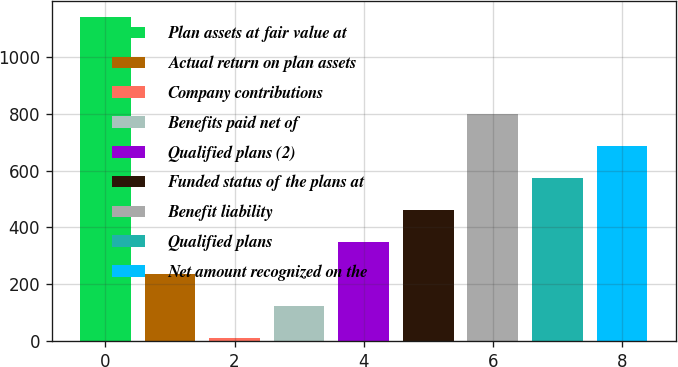Convert chart to OTSL. <chart><loc_0><loc_0><loc_500><loc_500><bar_chart><fcel>Plan assets at fair value at<fcel>Actual return on plan assets<fcel>Company contributions<fcel>Benefits paid net of<fcel>Qualified plans (2)<fcel>Funded status of the plans at<fcel>Benefit liability<fcel>Qualified plans<fcel>Net amount recognized on the<nl><fcel>1141<fcel>235.4<fcel>9<fcel>122.2<fcel>348.6<fcel>461.8<fcel>801.4<fcel>575<fcel>688.2<nl></chart> 